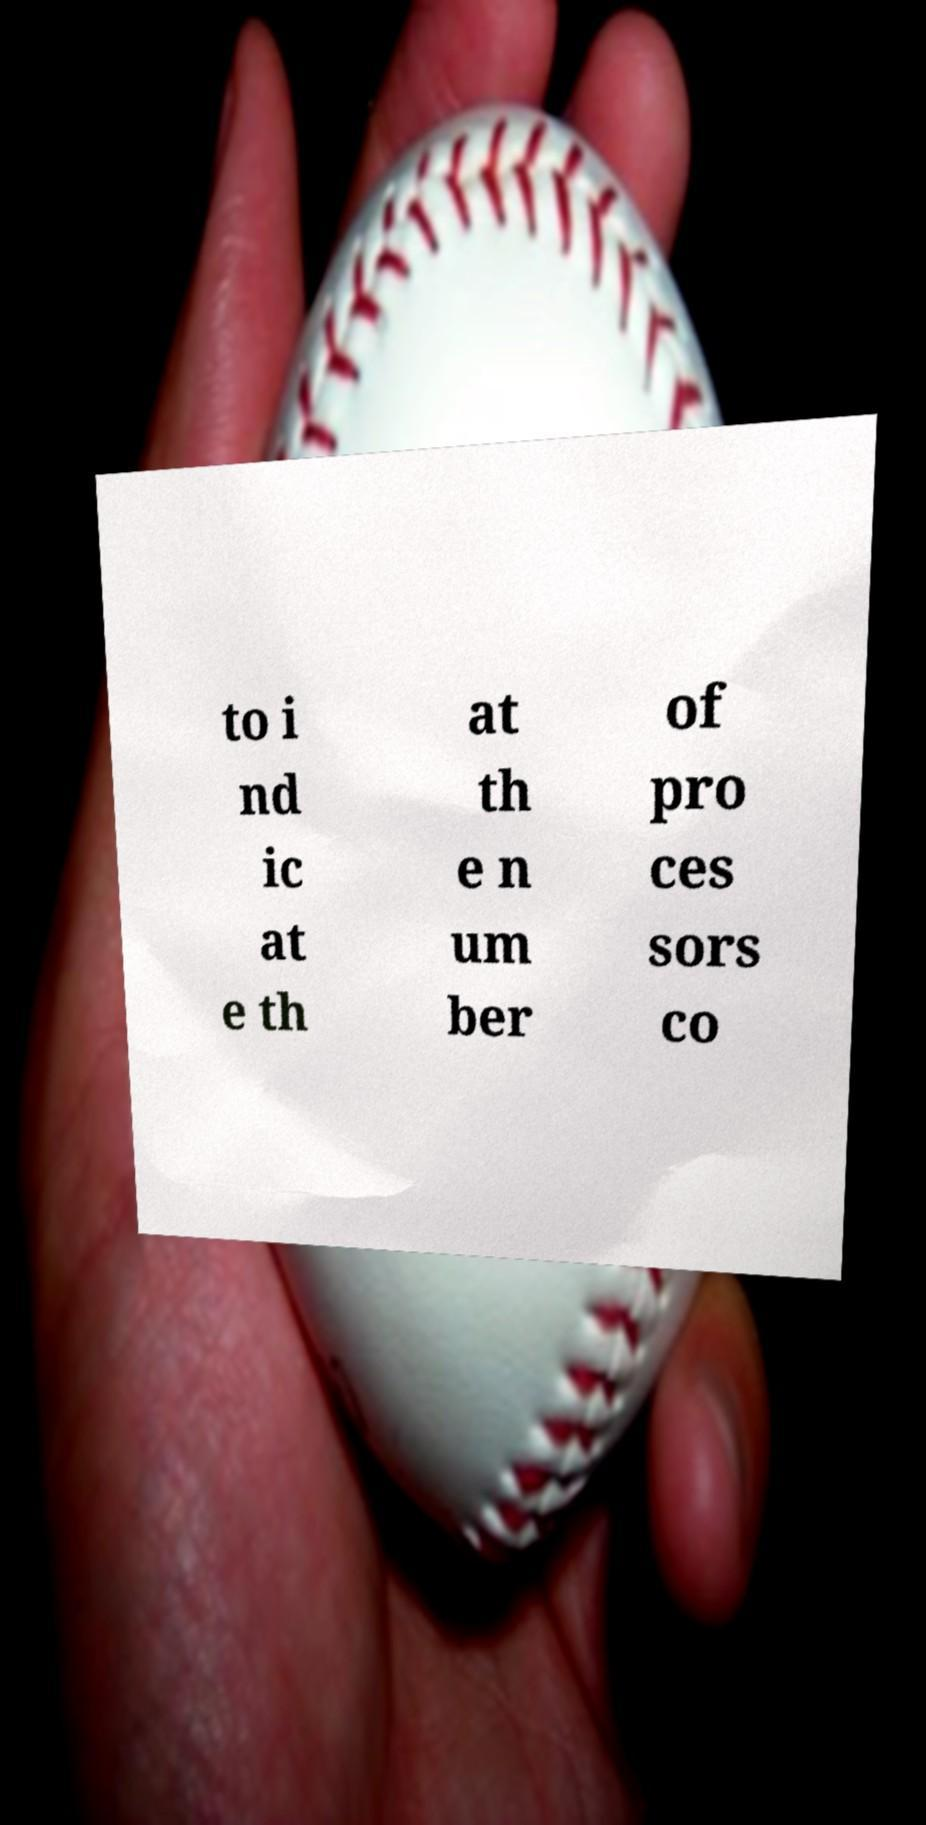There's text embedded in this image that I need extracted. Can you transcribe it verbatim? to i nd ic at e th at th e n um ber of pro ces sors co 